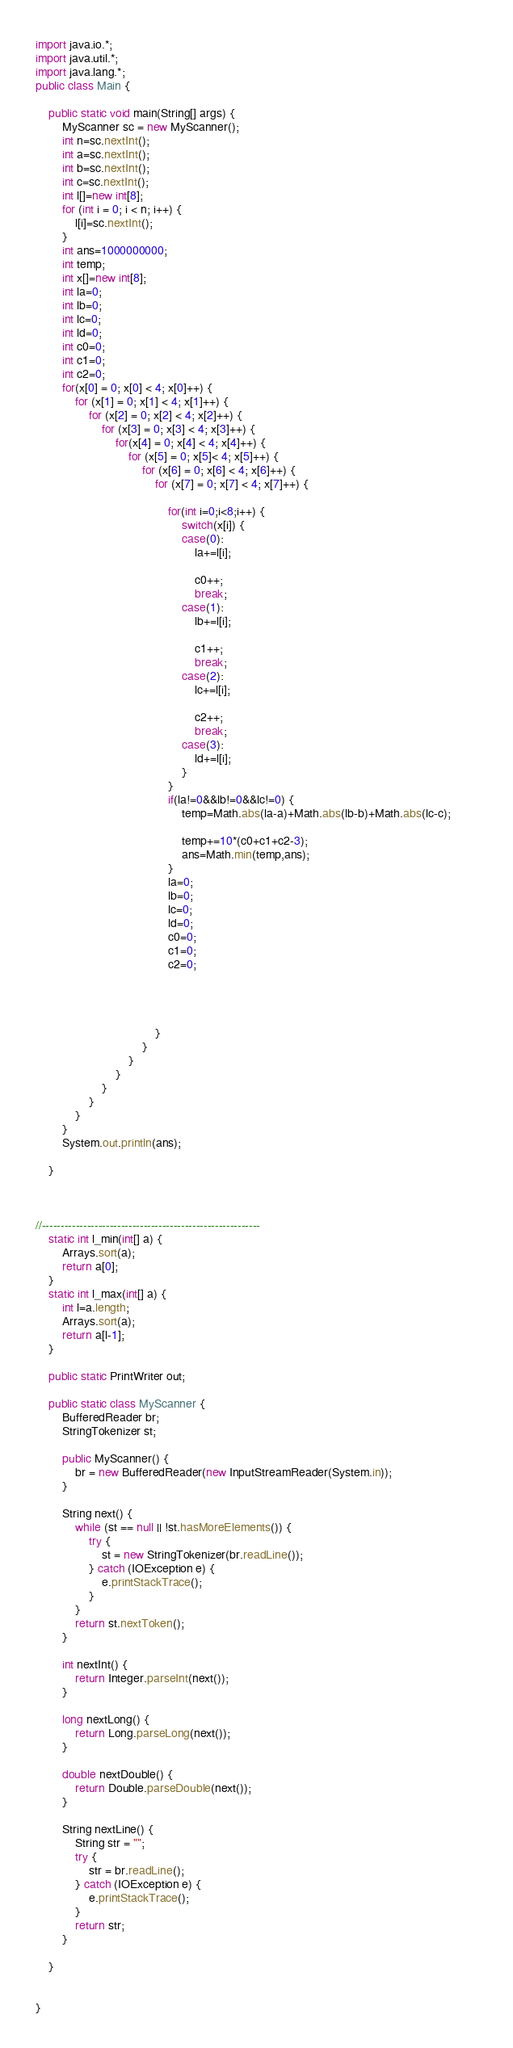Convert code to text. <code><loc_0><loc_0><loc_500><loc_500><_Java_>import java.io.*;
import java.util.*;
import java.lang.*;
public class Main {
	
	public static void main(String[] args) {
		MyScanner sc = new MyScanner();
		int n=sc.nextInt();
		int a=sc.nextInt();
		int b=sc.nextInt();
		int c=sc.nextInt();
		int l[]=new int[8];
		for (int i = 0; i < n; i++) {
			l[i]=sc.nextInt();
		}
		int ans=1000000000;
		int temp;
		int x[]=new int[8];
		int la=0;
		int lb=0;
		int lc=0;
		int ld=0;
		int c0=0;
		int c1=0;
		int c2=0;
		for(x[0] = 0; x[0] < 4; x[0]++) {
			for (x[1] = 0; x[1] < 4; x[1]++) {
				for (x[2] = 0; x[2] < 4; x[2]++) {
					for (x[3] = 0; x[3] < 4; x[3]++) {
						for(x[4] = 0; x[4] < 4; x[4]++) {
							for (x[5] = 0; x[5]< 4; x[5]++) {
								for (x[6] = 0; x[6] < 4; x[6]++) {
									for (x[7] = 0; x[7] < 4; x[7]++) {
										
										for(int i=0;i<8;i++) {
											switch(x[i]) {
											case(0):
												la+=l[i];
												
												c0++;
												break;
											case(1):
												lb+=l[i];
											
												c1++;
												break;
											case(2):	
												lc+=l[i];
											
												c2++;
												break;
											case(3):
												ld+=l[i];
											}
										}
										if(la!=0&&lb!=0&&lc!=0) {
											temp=Math.abs(la-a)+Math.abs(lb-b)+Math.abs(lc-c);		
											
											temp+=10*(c0+c1+c2-3);
											ans=Math.min(temp,ans);
										}
										la=0;
										lb=0;
										lc=0;
										ld=0;
										c0=0;
										c1=0;
										c2=0;
										
										
										
								
									}
								}
							}
						}	
					}
				}
			}
		}
		System.out.println(ans);
		
	}
	
	
	
//----------------------------------------------------------
	static int l_min(int[] a) {
		Arrays.sort(a);
		return a[0];
	}
	static int l_max(int[] a) {
		int l=a.length;
		Arrays.sort(a);
		return a[l-1];
	}
	
	public static PrintWriter out;

	public static class MyScanner {
		BufferedReader br;
		StringTokenizer st;

		public MyScanner() {
			br = new BufferedReader(new InputStreamReader(System.in));
		}

		String next() {
			while (st == null || !st.hasMoreElements()) {
				try {
					st = new StringTokenizer(br.readLine());
				} catch (IOException e) {
					e.printStackTrace();
				}
			}
			return st.nextToken();
		}

		int nextInt() {
			return Integer.parseInt(next());
		}

		long nextLong() {
			return Long.parseLong(next());
		}

		double nextDouble() {
			return Double.parseDouble(next());
		}

		String nextLine() {
			String str = "";
			try {
				str = br.readLine();
			} catch (IOException e) {
				e.printStackTrace();
			}
			return str;
		}

	}
	

}
</code> 